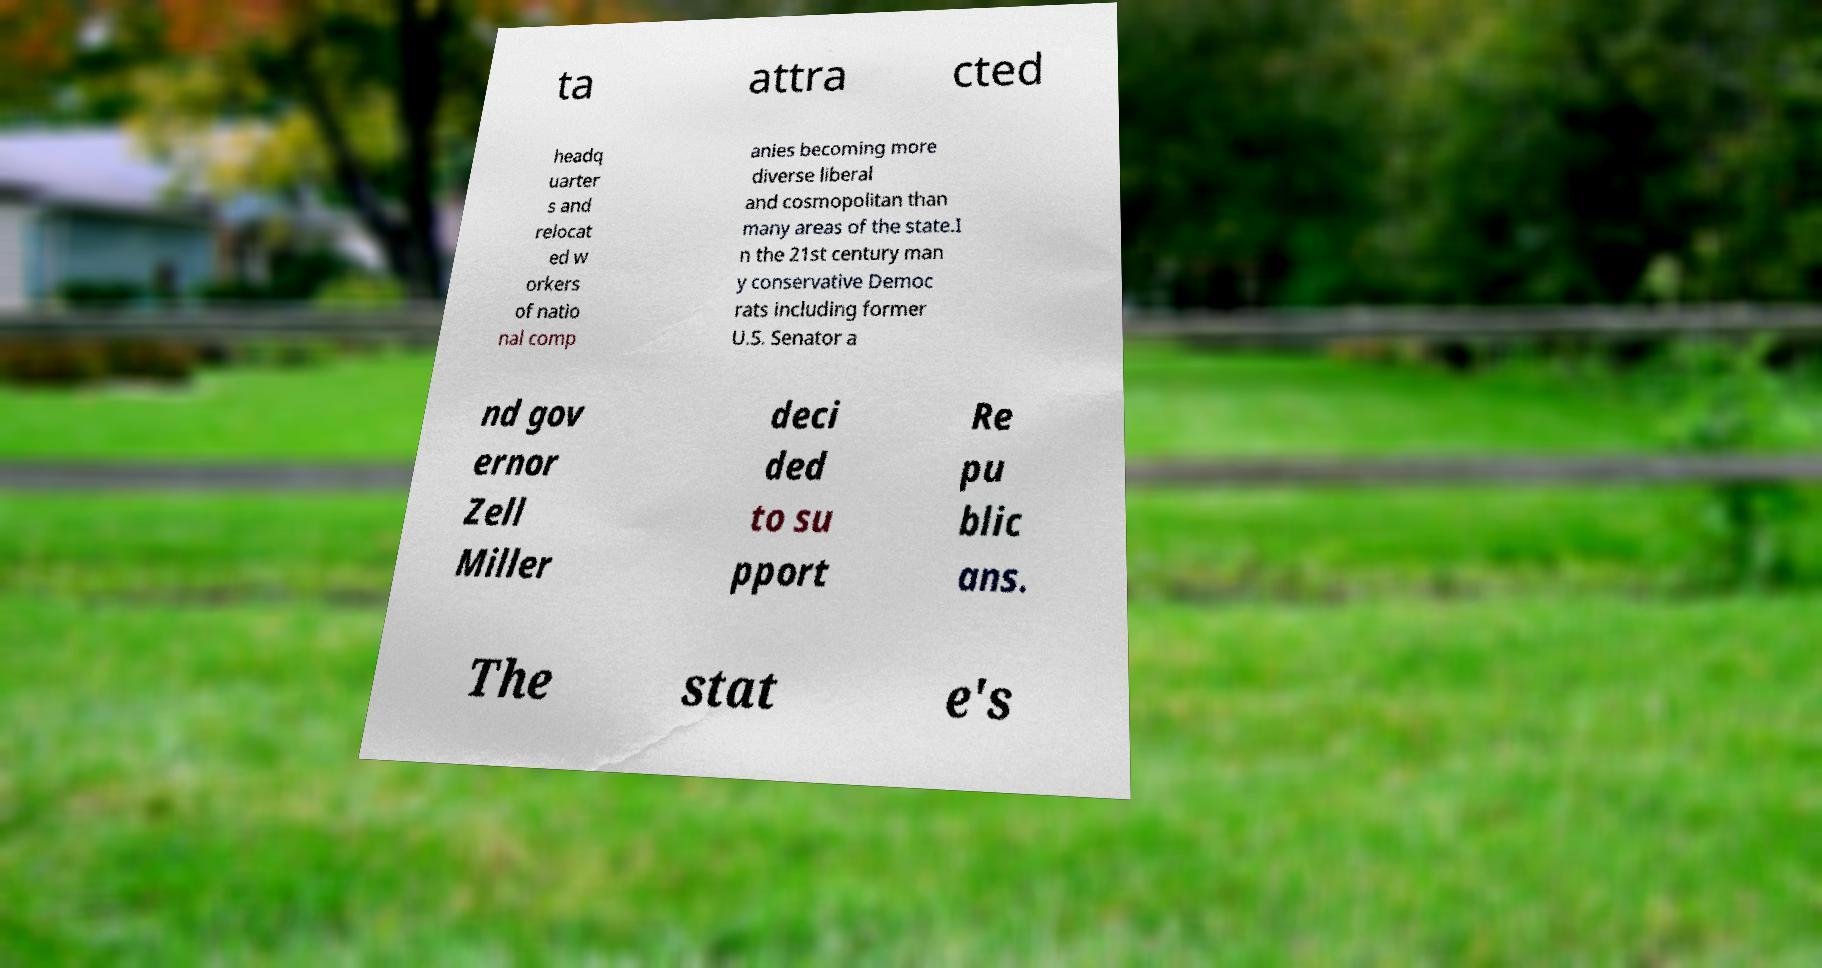There's text embedded in this image that I need extracted. Can you transcribe it verbatim? ta attra cted headq uarter s and relocat ed w orkers of natio nal comp anies becoming more diverse liberal and cosmopolitan than many areas of the state.I n the 21st century man y conservative Democ rats including former U.S. Senator a nd gov ernor Zell Miller deci ded to su pport Re pu blic ans. The stat e's 